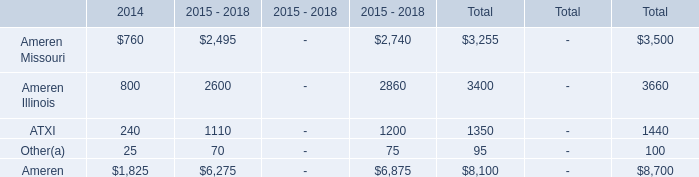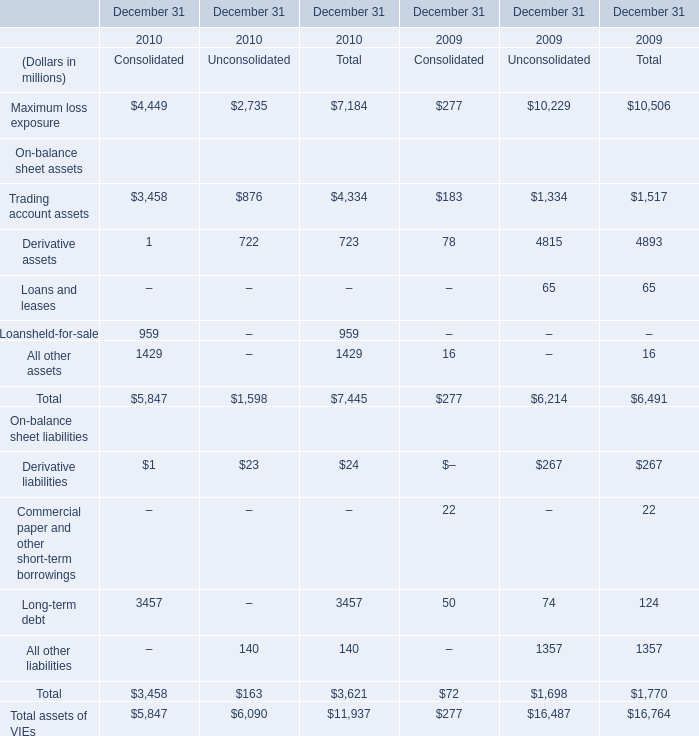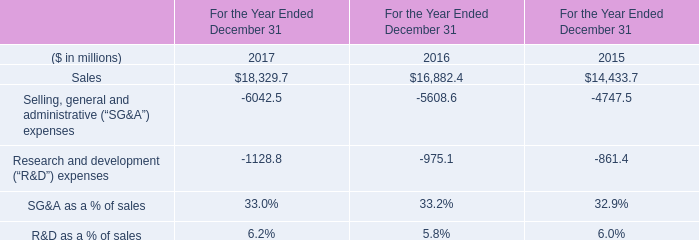What will the total long-term debt be like in 2011 if it develops with the same increasing rate as current? (in dollars in millions) 
Computations: (3457 * (1 + ((3457 - 124) / 124)))
Answer: 96377.81452. 